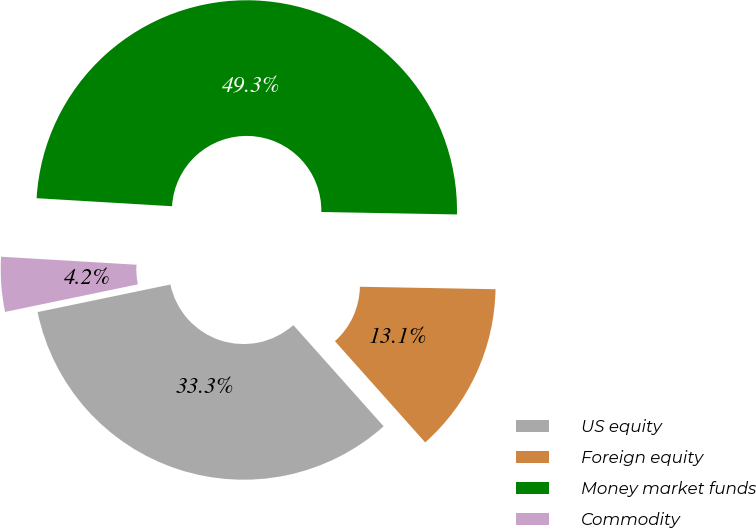Convert chart to OTSL. <chart><loc_0><loc_0><loc_500><loc_500><pie_chart><fcel>US equity<fcel>Foreign equity<fcel>Money market funds<fcel>Commodity<nl><fcel>33.33%<fcel>13.12%<fcel>49.34%<fcel>4.2%<nl></chart> 